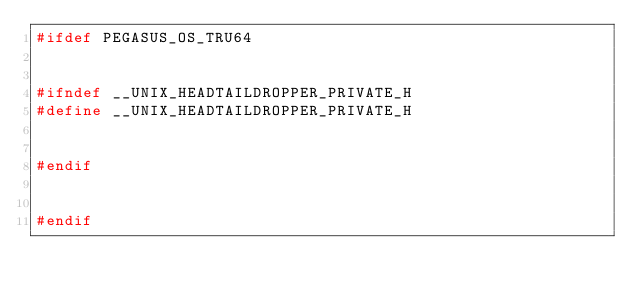<code> <loc_0><loc_0><loc_500><loc_500><_C++_>#ifdef PEGASUS_OS_TRU64


#ifndef __UNIX_HEADTAILDROPPER_PRIVATE_H
#define __UNIX_HEADTAILDROPPER_PRIVATE_H


#endif


#endif
</code> 